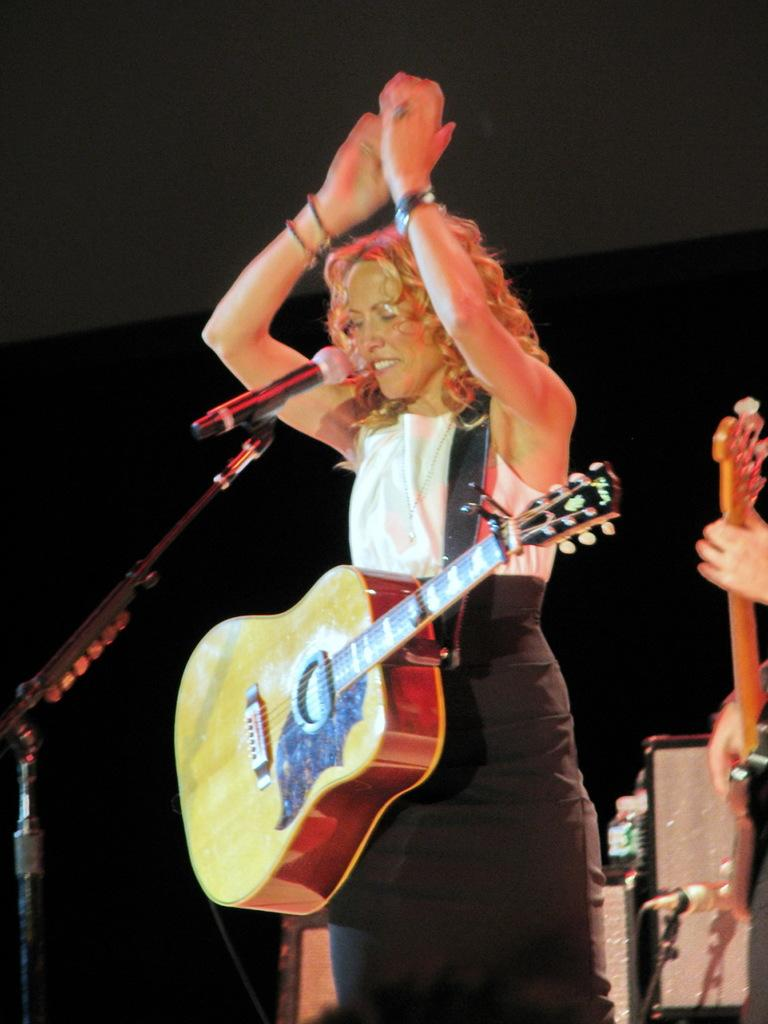Who is present in the image? There is a woman in the image. What is the woman doing in the image? The woman is standing and smiling in the image. What object is the woman holding? The woman is holding a guitar in the image. What is the purpose of the microphone in the image? The microphone is in front of the woman, likely for her to sing or speak into. What is the microphone stand used for? The microphone stand is used to hold and position the microphone. What type of balloon is floating above the woman's head in the image? There is no balloon present in the image; the woman is holding a guitar and standing near a microphone. 